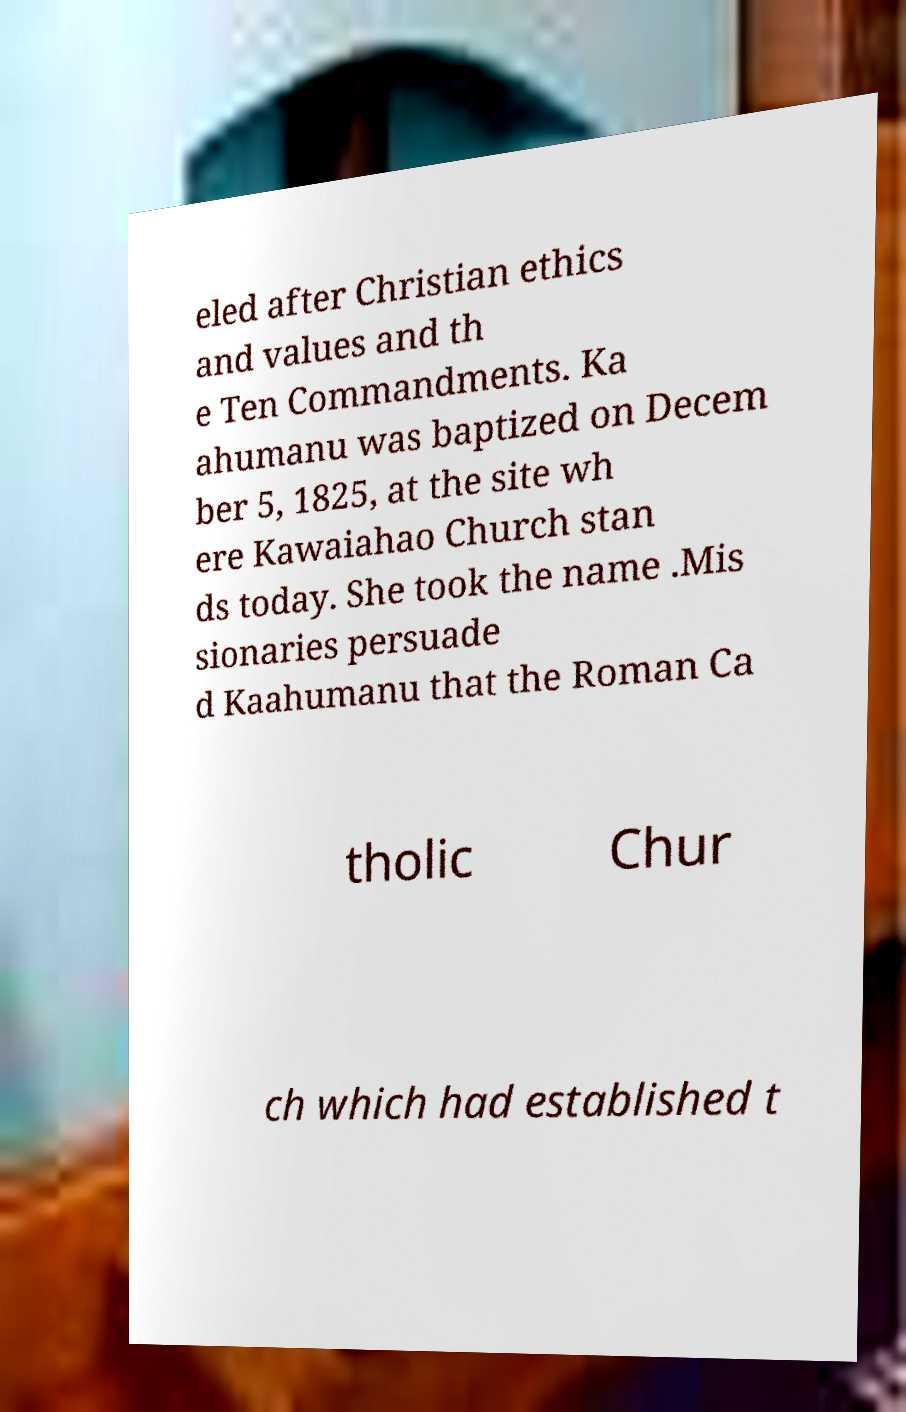Please identify and transcribe the text found in this image. eled after Christian ethics and values and th e Ten Commandments. Ka ahumanu was baptized on Decem ber 5, 1825, at the site wh ere Kawaiahao Church stan ds today. She took the name .Mis sionaries persuade d Kaahumanu that the Roman Ca tholic Chur ch which had established t 